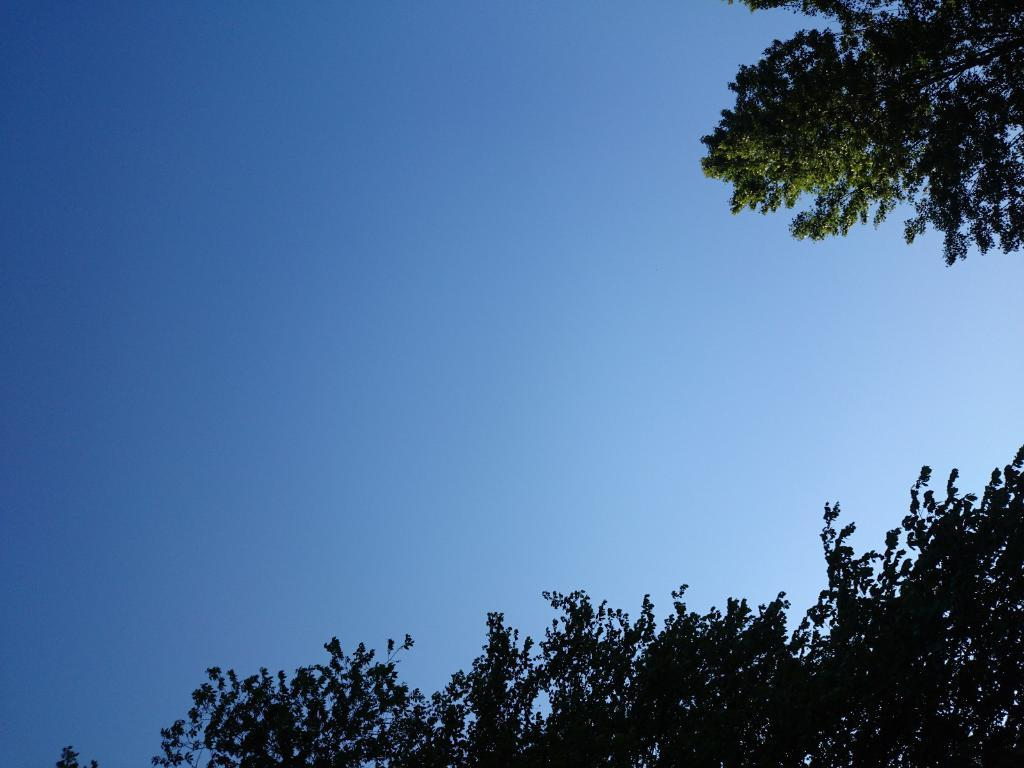What type of vegetation is visible at the bottom of the image? There are branches of a tree at the bottom of the image. Where else can tree branches be seen in the image? Tree branches are also visible on the right side of the image. What is visible in the background of the image? The sky is visible in the image. What is the condition of the sky in the image? The sky is clear in the image. What type of engine can be seen attached to the tree branches in the image? There is no engine present in the image; it features tree branches and a clear sky. What kind of waste is visible on the tree branches in the image? There is no waste present on the tree branches in the image; it only shows branches and a clear sky. 